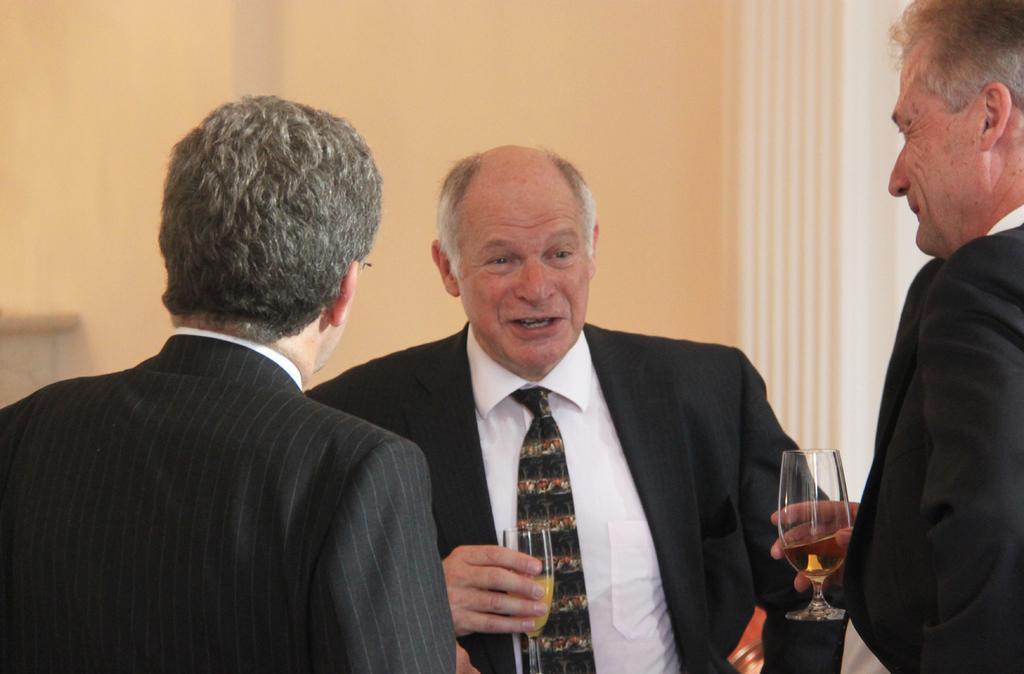Please provide a concise description of this image. In this image we can see some persons wearing coat. Some persons are holding glasses in their hands. In the background, we can see the wall. 